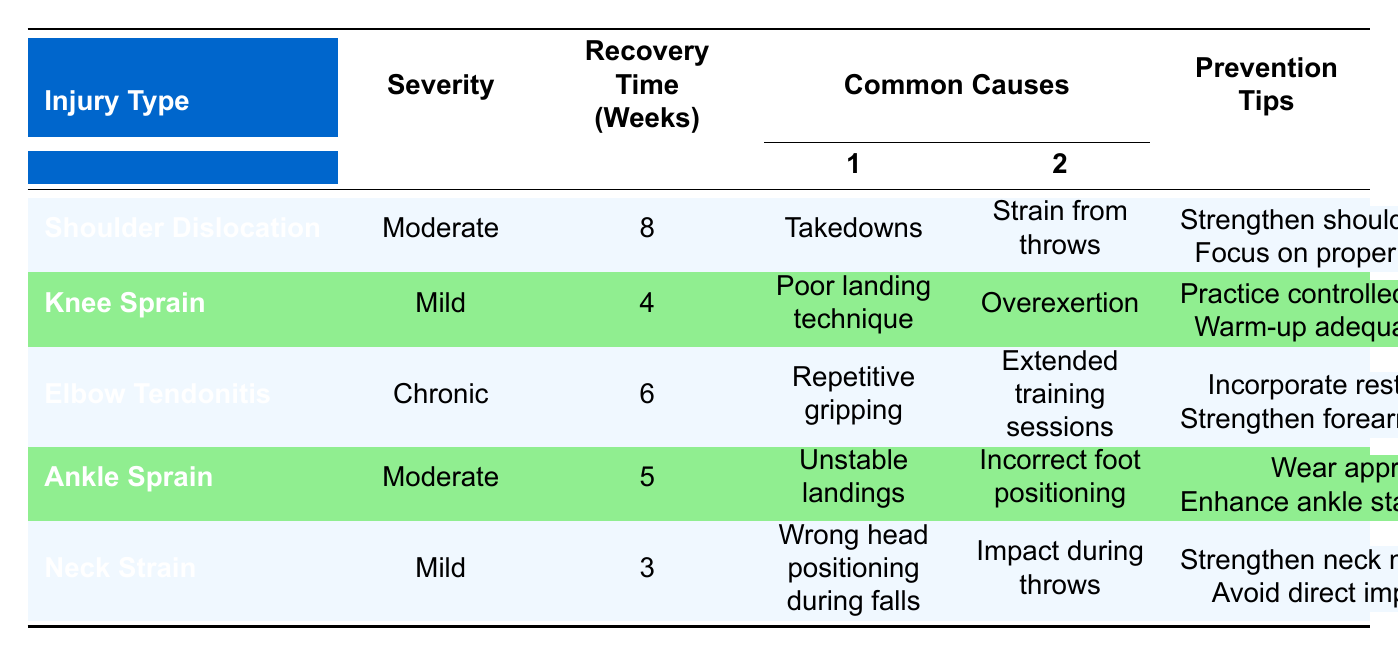What is the recovery time for a Shoulder Dislocation? The table specifies that the recovery time for a Shoulder Dislocation is listed in the "Recovery Time (Weeks)" column, which shows 8 weeks.
Answer: 8 weeks What are the common causes of a Knee Sprain? The "Common Causes" column for Knee Sprain lists two items: "Poor landing technique" and "Overexertion."
Answer: Poor landing technique, Overexertion Is the severity of an Elbow Tendonitis classified as mild? According to the "Severity" column for Elbow Tendonitis, it is listed as "Chronic," which means it is not mild. Therefore, the answer is no.
Answer: No What injury has the shortest recovery time? By looking at the recovery times, we find Neck Strain (3 weeks), which is less than all other injuries listed. Therefore, Neck Strain has the shortest recovery time.
Answer: Neck Strain How many injuries have a recovery time of 5 weeks or longer? The injuries with recovery times of 5 weeks or longer are Shoulder Dislocation (8 weeks), Elbow Tendonitis (6 weeks), Ankle Sprain (5 weeks), and one more injury which is Knee Sprain (4 weeks) not included since it is less than 5 weeks. In total, three injuries qualify.
Answer: 3 What prevention tips are recommended for an Ankle Sprain? The row for Ankle Sprain in the "Prevention Tips" column lists: "Wear appropriate footwear" and "Enhance ankle stability through exercises."
Answer: Wear appropriate footwear, Enhance ankle stability through exercises Are there any injuries listed with a severity rated as Mild? Scanning the "Severity" column reveals both Knee Sprain and Neck Strain are categorized under mild severity. Therefore, the answer is yes.
Answer: Yes Which injury type has the highest recovery time and what is that time? The injury type with the highest recovery time is Shoulder Dislocation with a recovery time of 8 weeks, as shown in the "Recovery Time (Weeks)" column. This indicates that Shoulder Dislocation has the longest recovery requirement.
Answer: Shoulder Dislocation, 8 weeks 